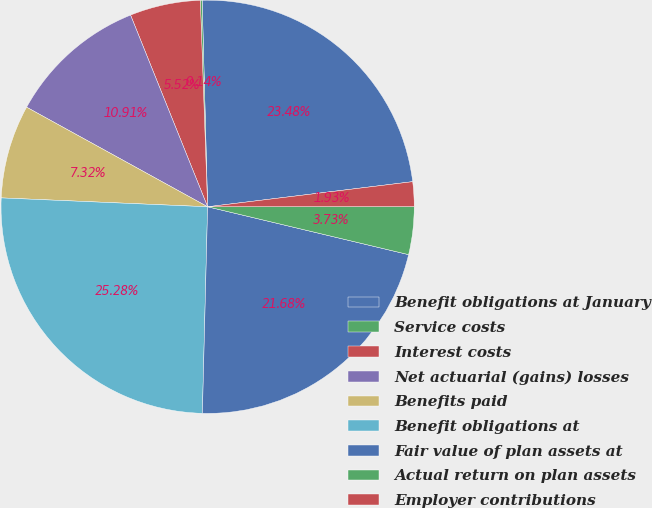Convert chart. <chart><loc_0><loc_0><loc_500><loc_500><pie_chart><fcel>Benefit obligations at January<fcel>Service costs<fcel>Interest costs<fcel>Net actuarial (gains) losses<fcel>Benefits paid<fcel>Benefit obligations at<fcel>Fair value of plan assets at<fcel>Actual return on plan assets<fcel>Employer contributions<nl><fcel>23.48%<fcel>0.14%<fcel>5.52%<fcel>10.91%<fcel>7.32%<fcel>25.28%<fcel>21.68%<fcel>3.73%<fcel>1.93%<nl></chart> 